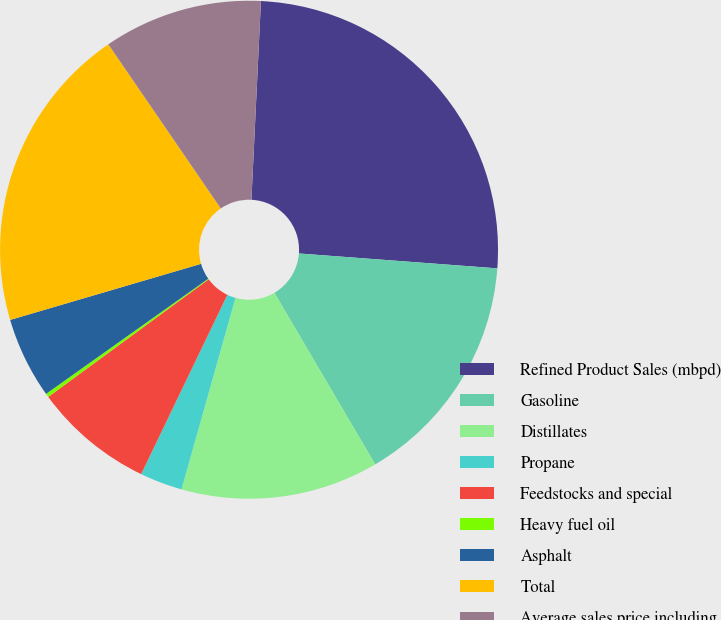Convert chart to OTSL. <chart><loc_0><loc_0><loc_500><loc_500><pie_chart><fcel>Refined Product Sales (mbpd)<fcel>Gasoline<fcel>Distillates<fcel>Propane<fcel>Feedstocks and special<fcel>Heavy fuel oil<fcel>Asphalt<fcel>Total<fcel>Average sales price including<nl><fcel>25.43%<fcel>15.35%<fcel>12.83%<fcel>2.76%<fcel>7.8%<fcel>0.24%<fcel>5.28%<fcel>19.99%<fcel>10.32%<nl></chart> 